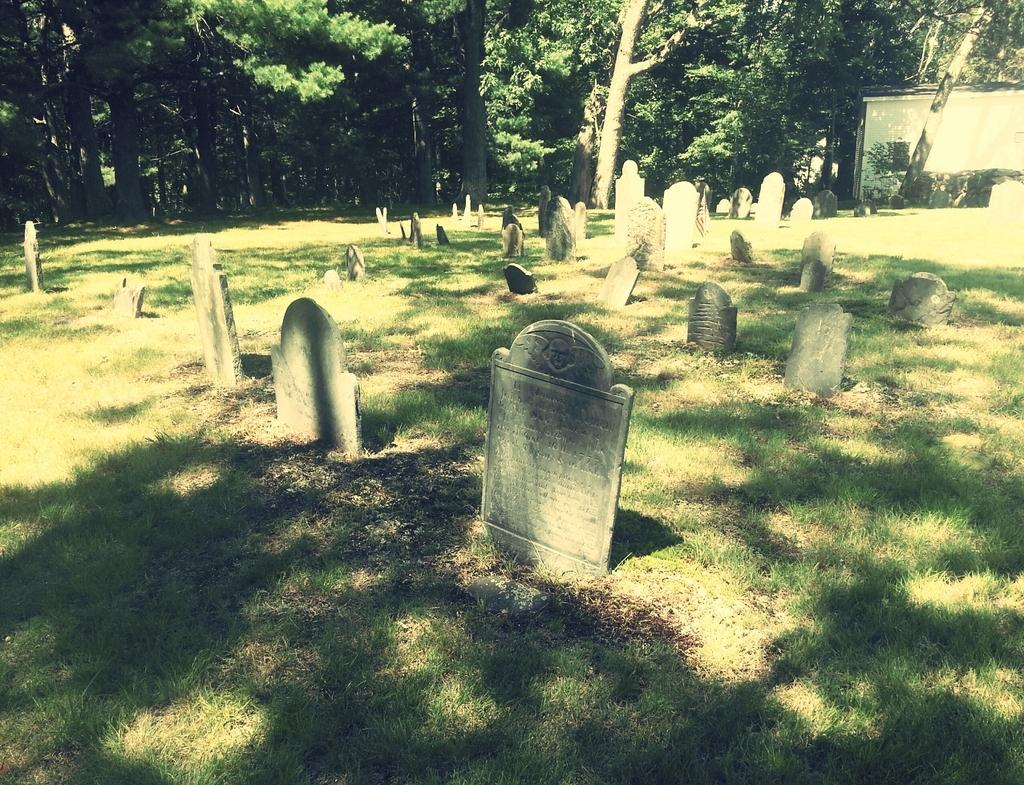What type of location is depicted in the image? There is a cemetery in the image. Are there any structures near the cemetery? Yes, there is a shed to the right of the cemetery. What can be seen in the background of the image? There are many trees in the background of the image. How long does it take for the trees to use the shed in the image? Trees do not use sheds, as they are inanimate objects. The question is not relevant to the image. 